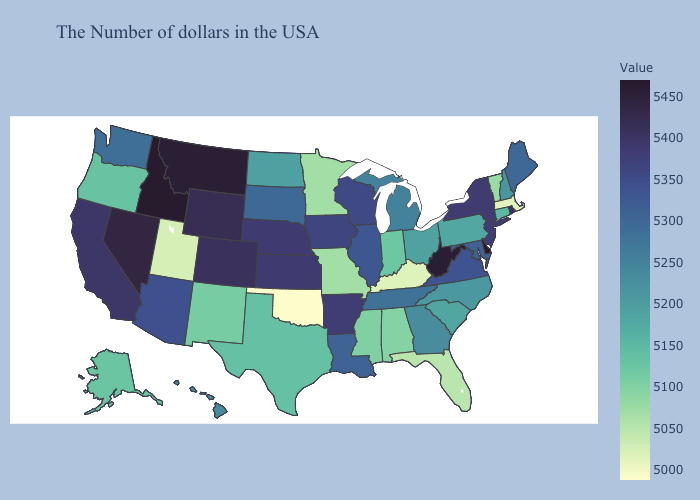Does North Dakota have a higher value than Arkansas?
Give a very brief answer. No. Which states have the lowest value in the USA?
Give a very brief answer. Oklahoma. Among the states that border Georgia , does Tennessee have the lowest value?
Concise answer only. No. Which states hav the highest value in the South?
Write a very short answer. Delaware. Does Florida have the lowest value in the USA?
Answer briefly. No. 